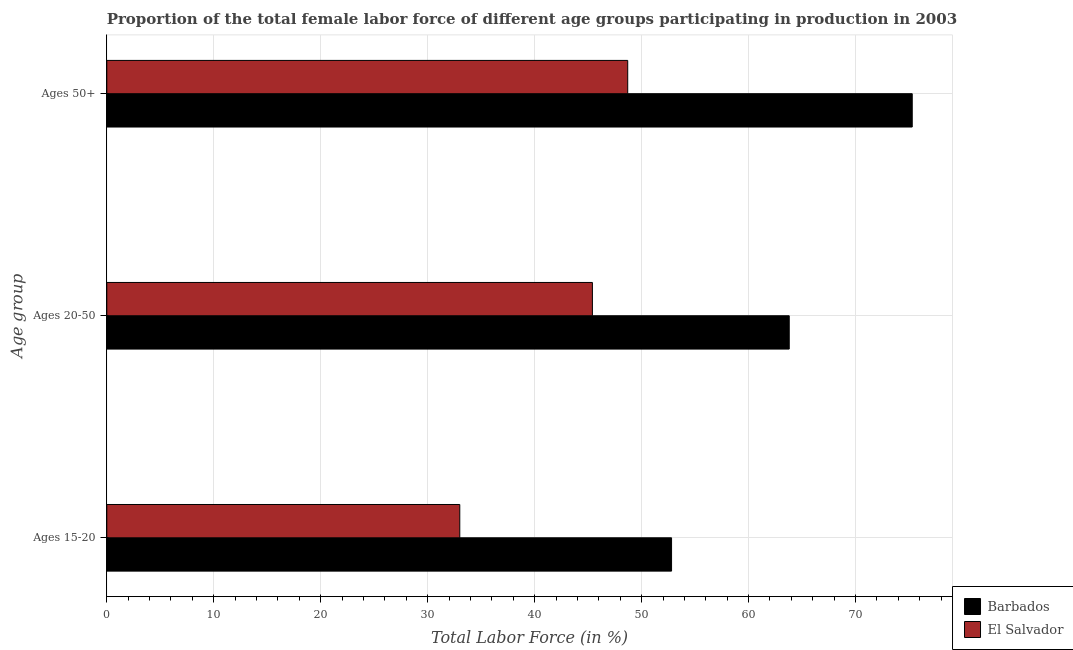How many different coloured bars are there?
Make the answer very short. 2. How many groups of bars are there?
Ensure brevity in your answer.  3. Are the number of bars per tick equal to the number of legend labels?
Your answer should be compact. Yes. How many bars are there on the 2nd tick from the top?
Your response must be concise. 2. What is the label of the 1st group of bars from the top?
Provide a short and direct response. Ages 50+. What is the percentage of female labor force above age 50 in Barbados?
Provide a succinct answer. 75.3. Across all countries, what is the maximum percentage of female labor force within the age group 15-20?
Provide a short and direct response. 52.8. In which country was the percentage of female labor force within the age group 20-50 maximum?
Give a very brief answer. Barbados. In which country was the percentage of female labor force within the age group 20-50 minimum?
Provide a succinct answer. El Salvador. What is the total percentage of female labor force within the age group 15-20 in the graph?
Make the answer very short. 85.8. What is the difference between the percentage of female labor force within the age group 20-50 in El Salvador and that in Barbados?
Your answer should be compact. -18.4. What is the difference between the percentage of female labor force above age 50 in Barbados and the percentage of female labor force within the age group 20-50 in El Salvador?
Make the answer very short. 29.9. What is the average percentage of female labor force above age 50 per country?
Offer a terse response. 62. What is the difference between the percentage of female labor force within the age group 20-50 and percentage of female labor force above age 50 in Barbados?
Provide a succinct answer. -11.5. What is the ratio of the percentage of female labor force above age 50 in El Salvador to that in Barbados?
Provide a succinct answer. 0.65. Is the difference between the percentage of female labor force above age 50 in Barbados and El Salvador greater than the difference between the percentage of female labor force within the age group 20-50 in Barbados and El Salvador?
Make the answer very short. Yes. What is the difference between the highest and the second highest percentage of female labor force within the age group 15-20?
Provide a short and direct response. 19.8. What is the difference between the highest and the lowest percentage of female labor force within the age group 20-50?
Provide a short and direct response. 18.4. In how many countries, is the percentage of female labor force within the age group 20-50 greater than the average percentage of female labor force within the age group 20-50 taken over all countries?
Offer a terse response. 1. What does the 2nd bar from the top in Ages 15-20 represents?
Your answer should be compact. Barbados. What does the 1st bar from the bottom in Ages 15-20 represents?
Provide a short and direct response. Barbados. Are all the bars in the graph horizontal?
Keep it short and to the point. Yes. How many countries are there in the graph?
Offer a terse response. 2. What is the difference between two consecutive major ticks on the X-axis?
Ensure brevity in your answer.  10. Where does the legend appear in the graph?
Provide a short and direct response. Bottom right. How are the legend labels stacked?
Keep it short and to the point. Vertical. What is the title of the graph?
Provide a succinct answer. Proportion of the total female labor force of different age groups participating in production in 2003. What is the label or title of the Y-axis?
Your answer should be compact. Age group. What is the Total Labor Force (in %) of Barbados in Ages 15-20?
Your response must be concise. 52.8. What is the Total Labor Force (in %) of El Salvador in Ages 15-20?
Offer a very short reply. 33. What is the Total Labor Force (in %) in Barbados in Ages 20-50?
Your answer should be compact. 63.8. What is the Total Labor Force (in %) of El Salvador in Ages 20-50?
Make the answer very short. 45.4. What is the Total Labor Force (in %) in Barbados in Ages 50+?
Your response must be concise. 75.3. What is the Total Labor Force (in %) of El Salvador in Ages 50+?
Keep it short and to the point. 48.7. Across all Age group, what is the maximum Total Labor Force (in %) of Barbados?
Your answer should be very brief. 75.3. Across all Age group, what is the maximum Total Labor Force (in %) of El Salvador?
Keep it short and to the point. 48.7. Across all Age group, what is the minimum Total Labor Force (in %) of Barbados?
Ensure brevity in your answer.  52.8. Across all Age group, what is the minimum Total Labor Force (in %) of El Salvador?
Ensure brevity in your answer.  33. What is the total Total Labor Force (in %) in Barbados in the graph?
Offer a terse response. 191.9. What is the total Total Labor Force (in %) in El Salvador in the graph?
Your answer should be compact. 127.1. What is the difference between the Total Labor Force (in %) in Barbados in Ages 15-20 and that in Ages 20-50?
Keep it short and to the point. -11. What is the difference between the Total Labor Force (in %) of El Salvador in Ages 15-20 and that in Ages 20-50?
Offer a terse response. -12.4. What is the difference between the Total Labor Force (in %) in Barbados in Ages 15-20 and that in Ages 50+?
Your response must be concise. -22.5. What is the difference between the Total Labor Force (in %) of El Salvador in Ages 15-20 and that in Ages 50+?
Make the answer very short. -15.7. What is the difference between the Total Labor Force (in %) in Barbados in Ages 20-50 and that in Ages 50+?
Provide a short and direct response. -11.5. What is the difference between the Total Labor Force (in %) of El Salvador in Ages 20-50 and that in Ages 50+?
Ensure brevity in your answer.  -3.3. What is the average Total Labor Force (in %) of Barbados per Age group?
Your answer should be compact. 63.97. What is the average Total Labor Force (in %) in El Salvador per Age group?
Offer a terse response. 42.37. What is the difference between the Total Labor Force (in %) in Barbados and Total Labor Force (in %) in El Salvador in Ages 15-20?
Offer a very short reply. 19.8. What is the difference between the Total Labor Force (in %) in Barbados and Total Labor Force (in %) in El Salvador in Ages 50+?
Provide a short and direct response. 26.6. What is the ratio of the Total Labor Force (in %) of Barbados in Ages 15-20 to that in Ages 20-50?
Your response must be concise. 0.83. What is the ratio of the Total Labor Force (in %) in El Salvador in Ages 15-20 to that in Ages 20-50?
Provide a short and direct response. 0.73. What is the ratio of the Total Labor Force (in %) of Barbados in Ages 15-20 to that in Ages 50+?
Ensure brevity in your answer.  0.7. What is the ratio of the Total Labor Force (in %) in El Salvador in Ages 15-20 to that in Ages 50+?
Your answer should be compact. 0.68. What is the ratio of the Total Labor Force (in %) in Barbados in Ages 20-50 to that in Ages 50+?
Make the answer very short. 0.85. What is the ratio of the Total Labor Force (in %) in El Salvador in Ages 20-50 to that in Ages 50+?
Your answer should be very brief. 0.93. What is the difference between the highest and the lowest Total Labor Force (in %) in El Salvador?
Your answer should be very brief. 15.7. 